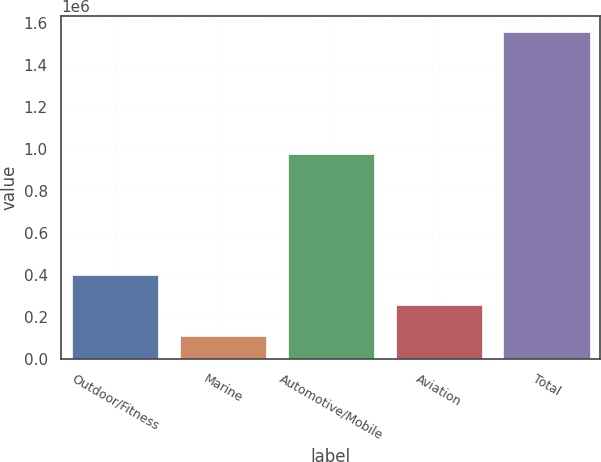Convert chart to OTSL. <chart><loc_0><loc_0><loc_500><loc_500><bar_chart><fcel>Outdoor/Fitness<fcel>Marine<fcel>Automotive/Mobile<fcel>Aviation<fcel>Total<nl><fcel>399843<fcel>111425<fcel>977595<fcel>255634<fcel>1.55352e+06<nl></chart> 